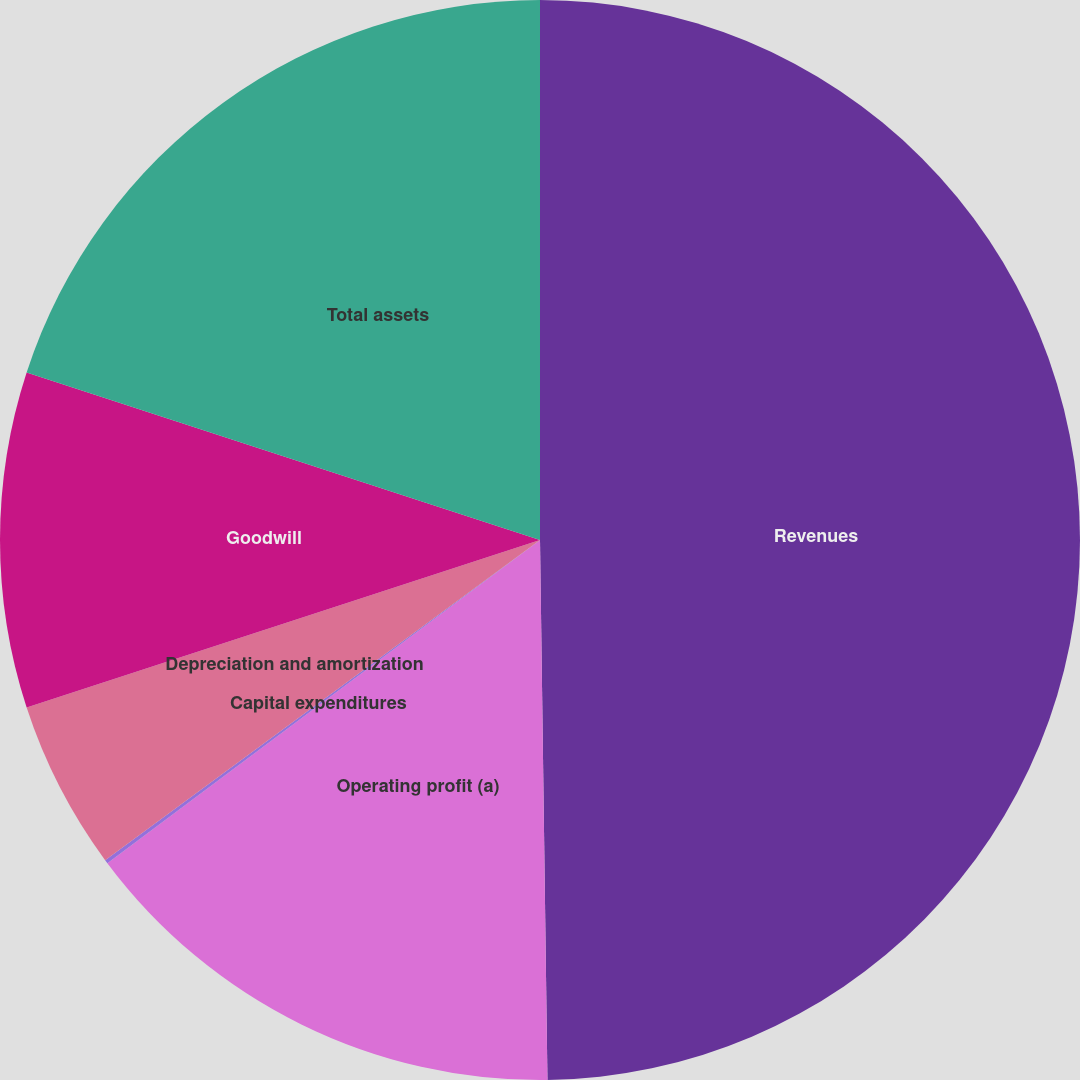Convert chart. <chart><loc_0><loc_0><loc_500><loc_500><pie_chart><fcel>Revenues<fcel>Operating profit (a)<fcel>Capital expenditures<fcel>Depreciation and amortization<fcel>Goodwill<fcel>Total assets<nl><fcel>49.78%<fcel>15.01%<fcel>0.11%<fcel>5.08%<fcel>10.04%<fcel>19.98%<nl></chart> 